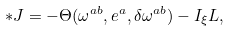<formula> <loc_0><loc_0><loc_500><loc_500>\ast J = - \Theta ( \omega ^ { a b } , e ^ { a } , \delta \omega ^ { a b } ) - I _ { \xi } L ,</formula> 